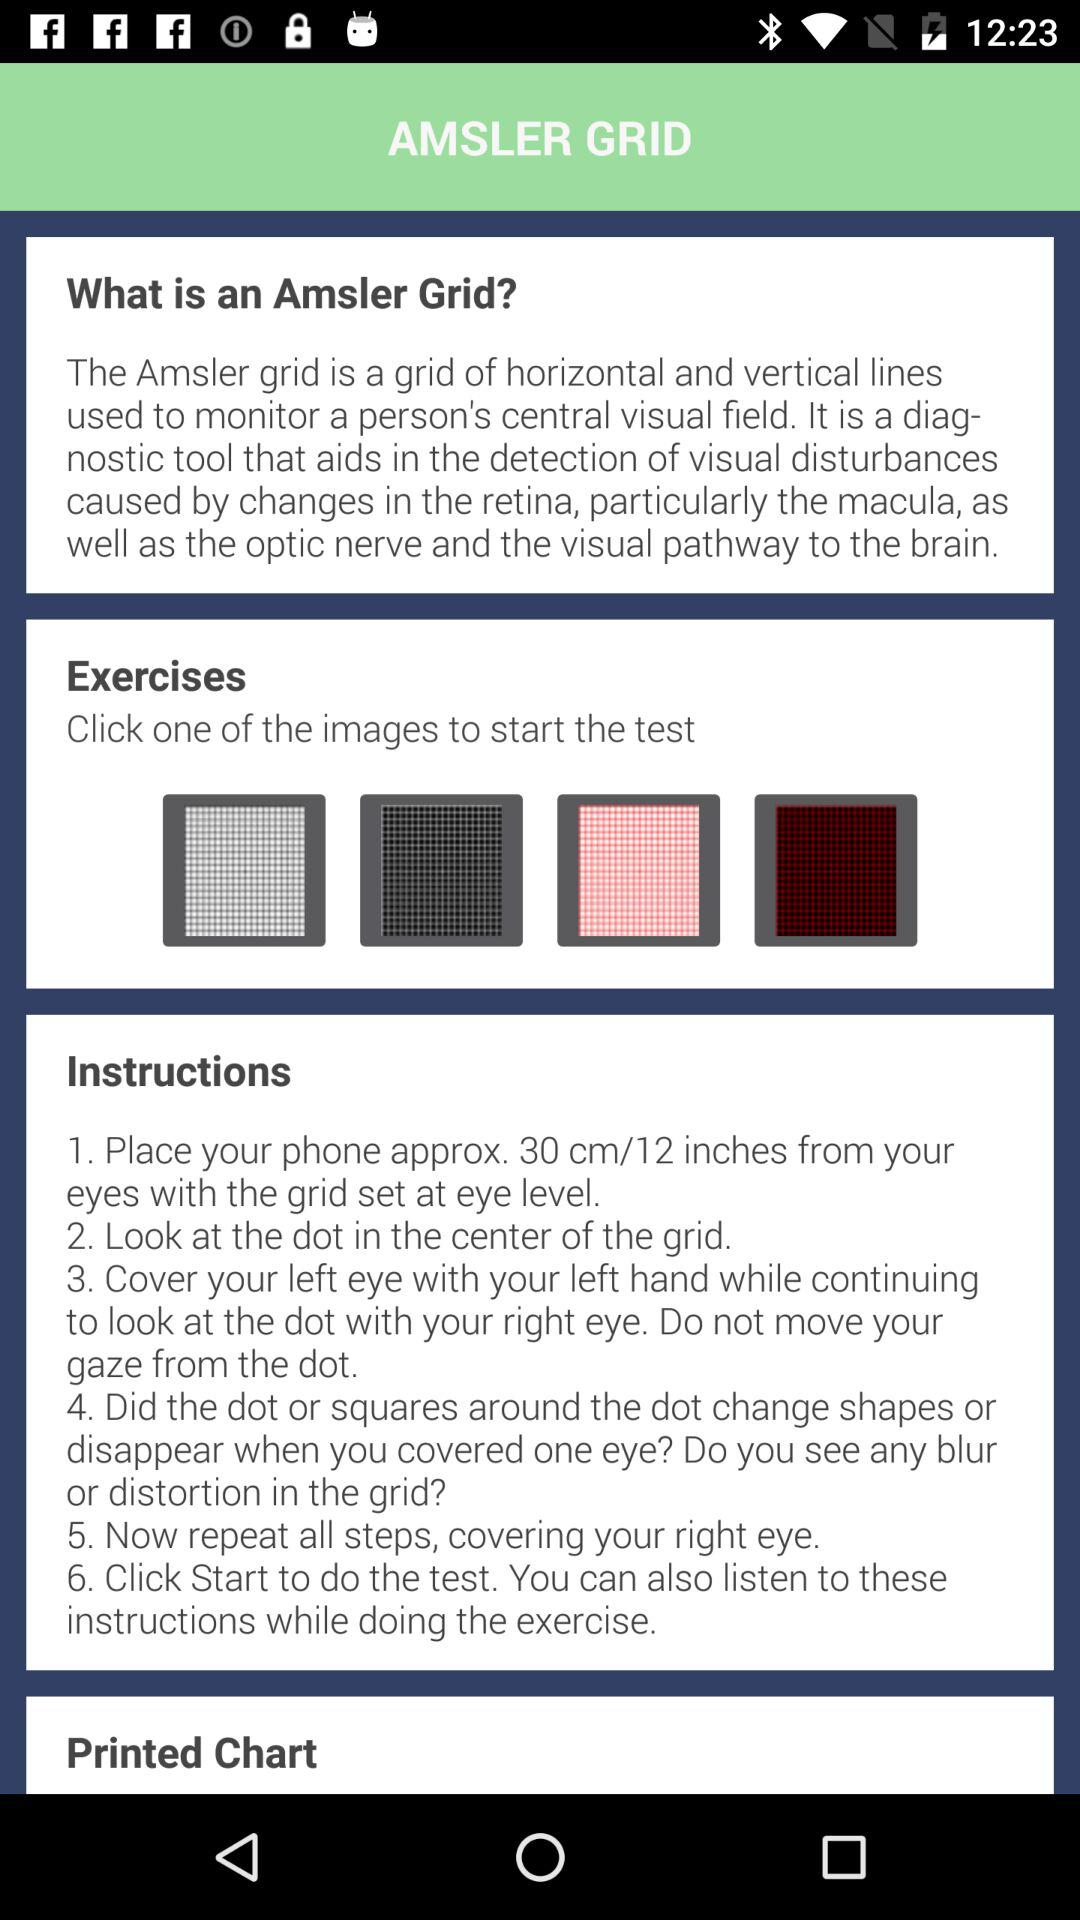What is the name of the topic? The name of the topic is "AMSLER GRID". 